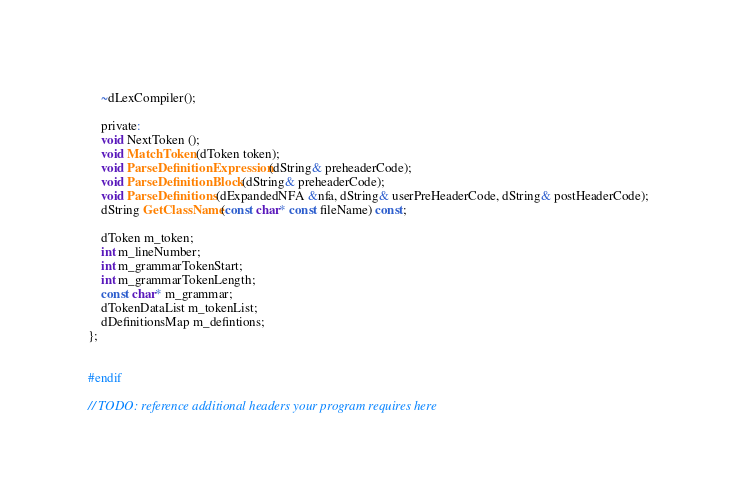Convert code to text. <code><loc_0><loc_0><loc_500><loc_500><_C_>	~dLexCompiler();

	private:
	void NextToken ();
	void MatchToken (dToken token);
	void ParseDefinitionExpression (dString& preheaderCode);
	void ParseDefinitionBlock (dString& preheaderCode);
	void ParseDefinitions (dExpandedNFA &nfa, dString& userPreHeaderCode, dString& postHeaderCode);
	dString GetClassName(const char* const fileName) const;

	dToken m_token;
	int m_lineNumber;
	int m_grammarTokenStart;
	int m_grammarTokenLength;
	const char* m_grammar;
	dTokenDataList m_tokenList;
	dDefinitionsMap m_defintions;
};


#endif

// TODO: reference additional headers your program requires here
</code> 